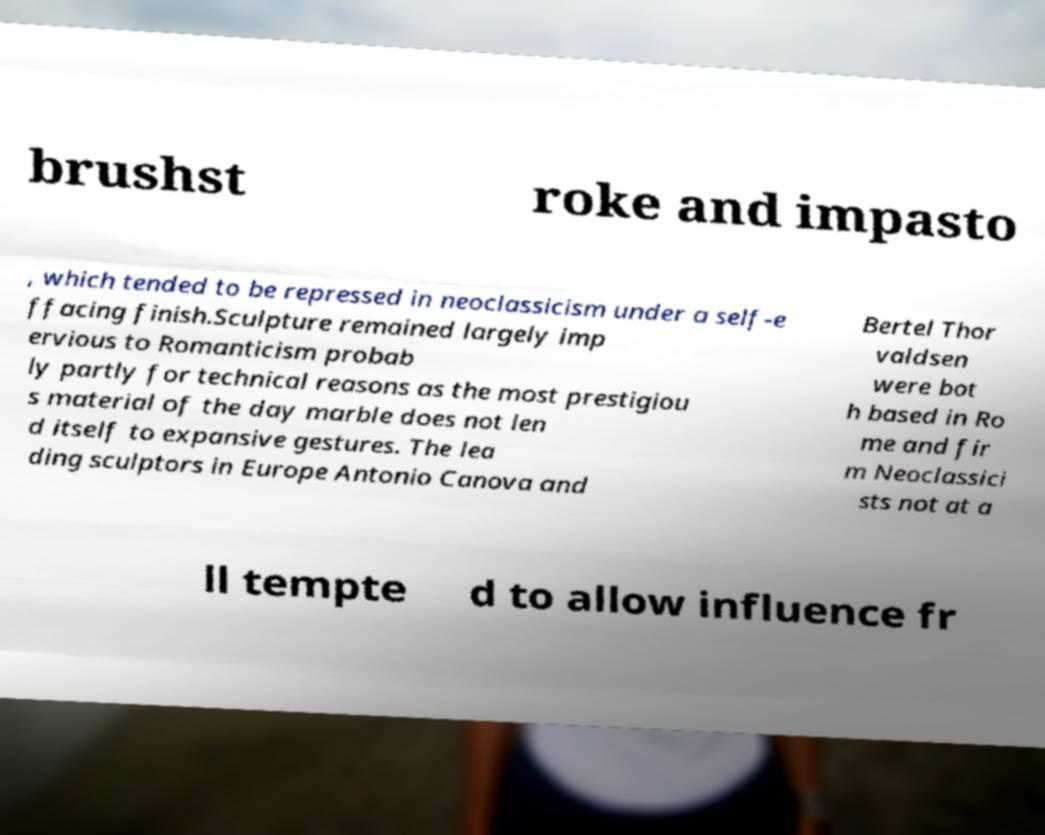There's text embedded in this image that I need extracted. Can you transcribe it verbatim? brushst roke and impasto , which tended to be repressed in neoclassicism under a self-e ffacing finish.Sculpture remained largely imp ervious to Romanticism probab ly partly for technical reasons as the most prestigiou s material of the day marble does not len d itself to expansive gestures. The lea ding sculptors in Europe Antonio Canova and Bertel Thor valdsen were bot h based in Ro me and fir m Neoclassici sts not at a ll tempte d to allow influence fr 